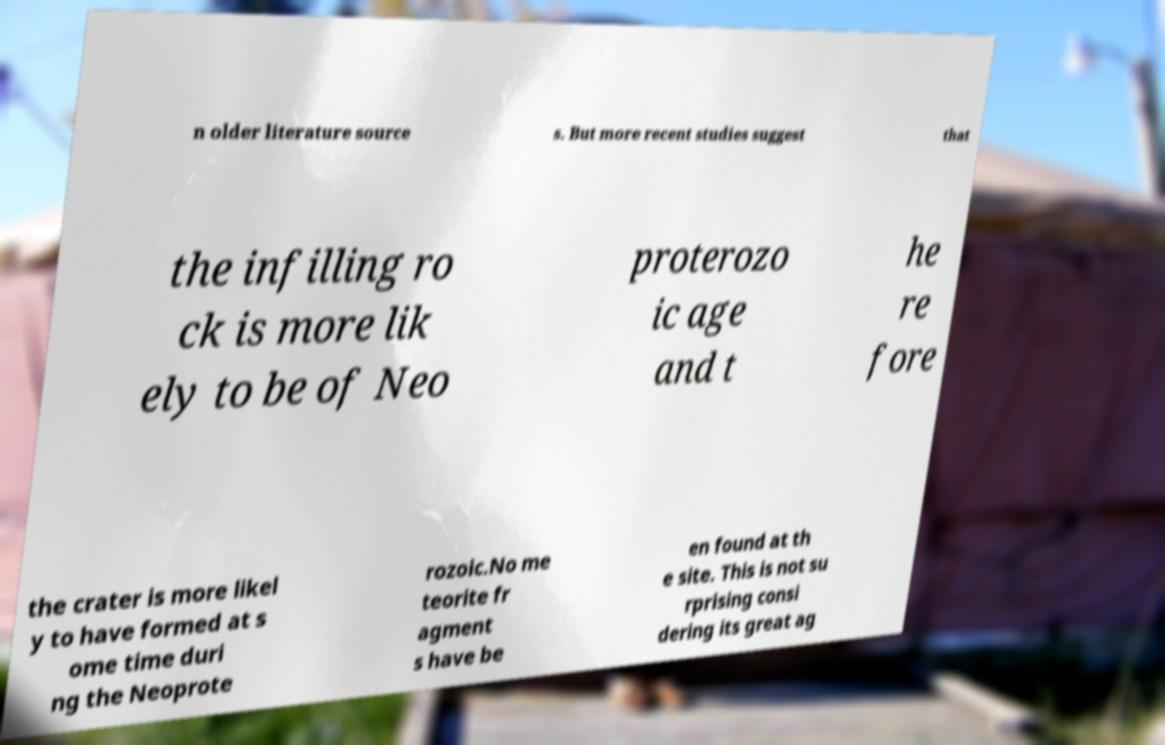Please read and relay the text visible in this image. What does it say? n older literature source s. But more recent studies suggest that the infilling ro ck is more lik ely to be of Neo proterozo ic age and t he re fore the crater is more likel y to have formed at s ome time duri ng the Neoprote rozoic.No me teorite fr agment s have be en found at th e site. This is not su rprising consi dering its great ag 